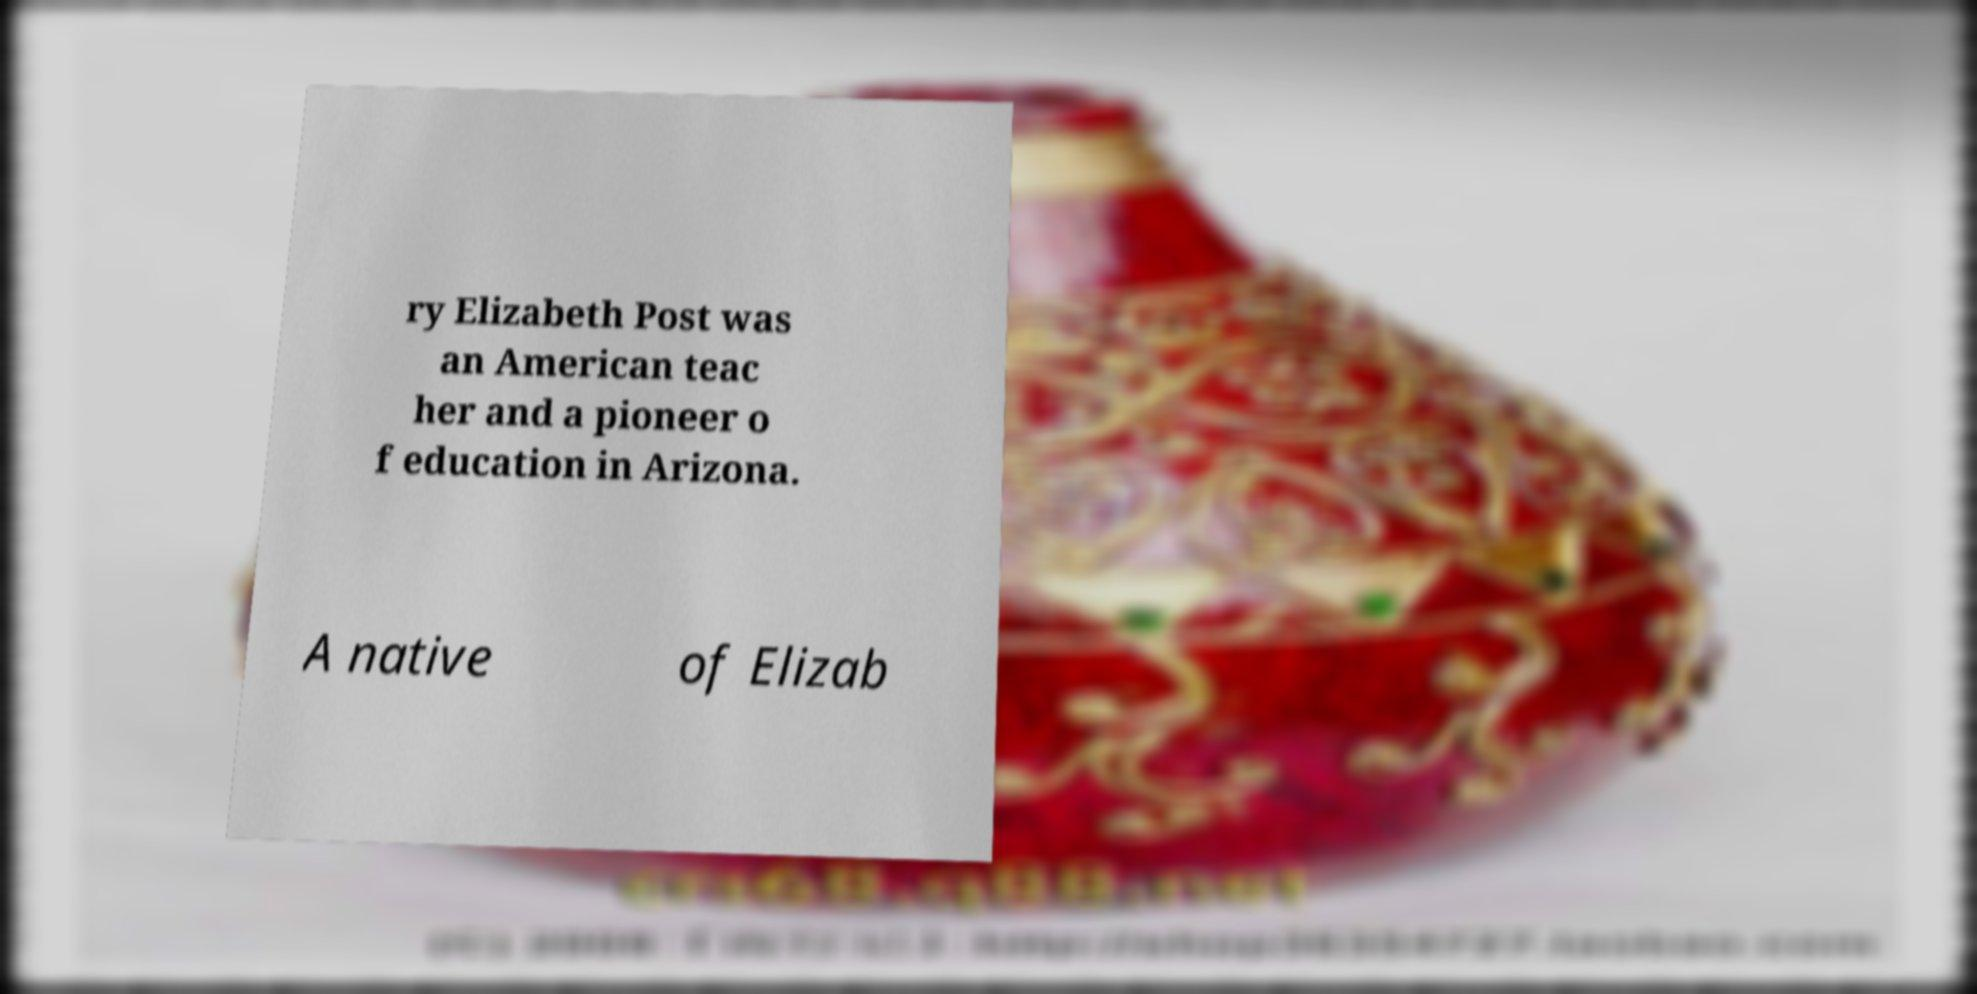Could you assist in decoding the text presented in this image and type it out clearly? ry Elizabeth Post was an American teac her and a pioneer o f education in Arizona. A native of Elizab 